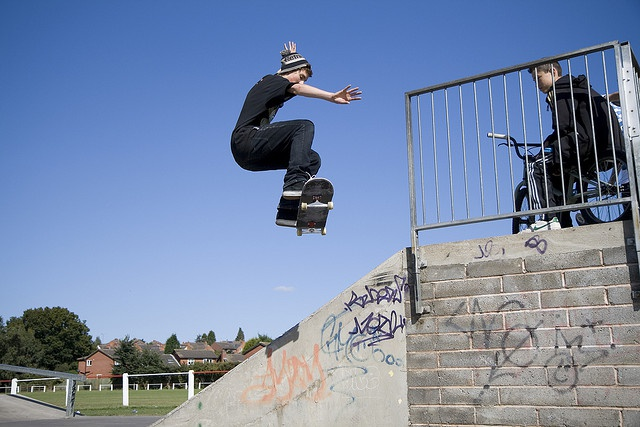Describe the objects in this image and their specific colors. I can see people in blue, black, gray, and lightgray tones, people in blue, black, gray, lightgray, and darkgray tones, bicycle in blue, black, darkgray, and gray tones, backpack in blue, black, lightgray, and gray tones, and skateboard in blue, black, gray, and darkgray tones in this image. 